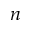Convert formula to latex. <formula><loc_0><loc_0><loc_500><loc_500>n</formula> 